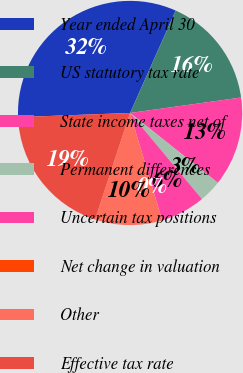Convert chart to OTSL. <chart><loc_0><loc_0><loc_500><loc_500><pie_chart><fcel>Year ended April 30<fcel>US statutory tax rate<fcel>State income taxes net of<fcel>Permanent differences<fcel>Uncertain tax positions<fcel>Net change in valuation<fcel>Other<fcel>Effective tax rate<nl><fcel>32.25%<fcel>16.13%<fcel>12.9%<fcel>3.23%<fcel>6.45%<fcel>0.0%<fcel>9.68%<fcel>19.35%<nl></chart> 